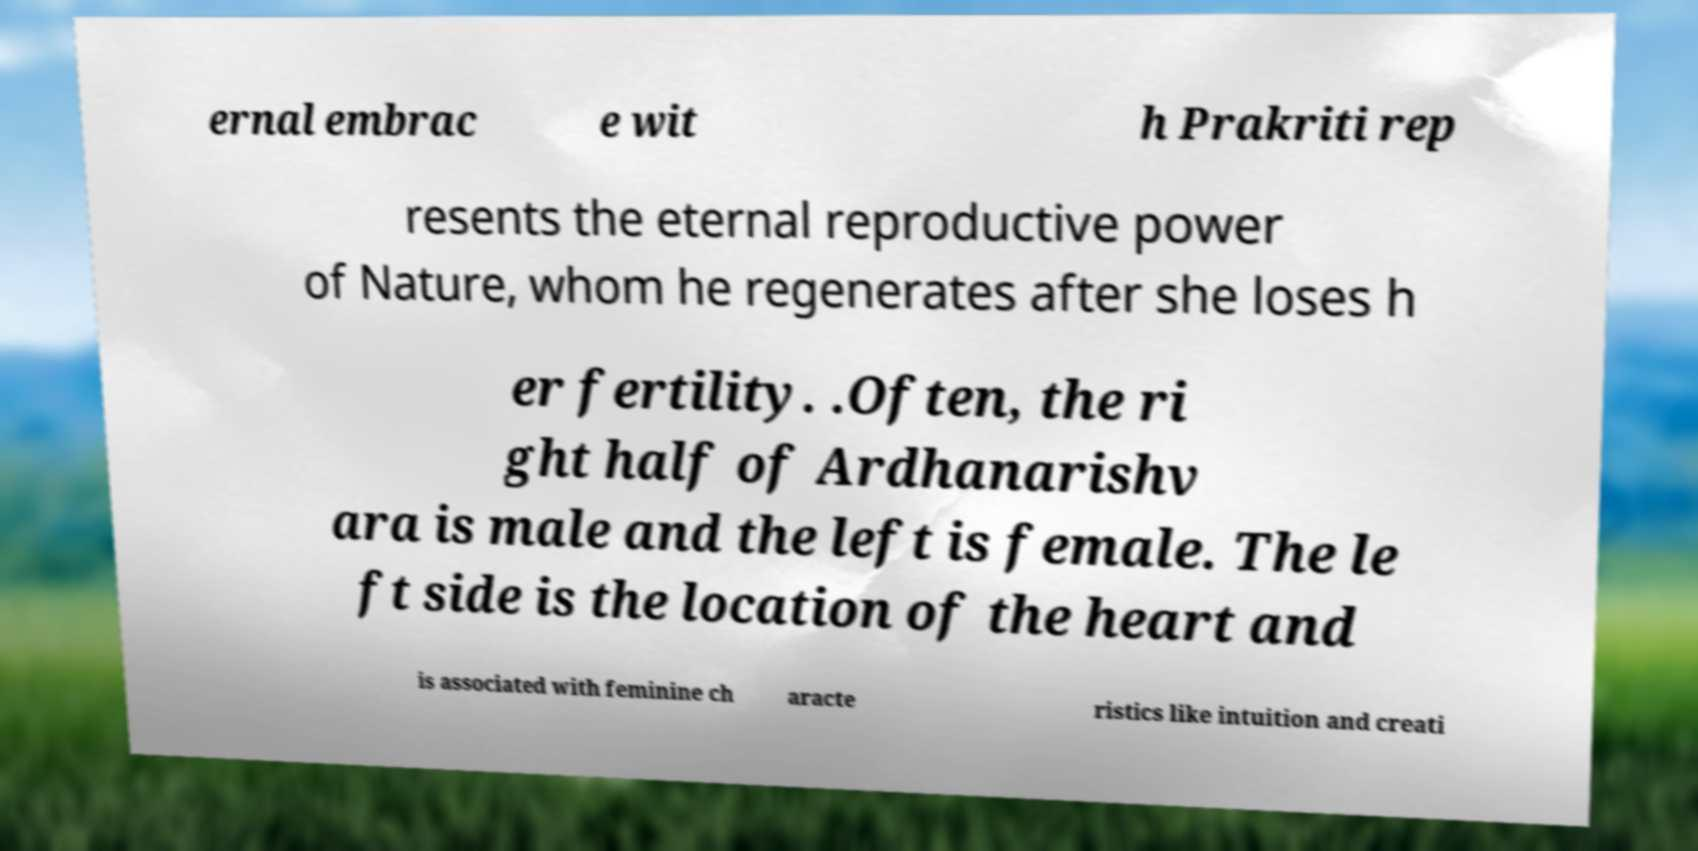Could you assist in decoding the text presented in this image and type it out clearly? ernal embrac e wit h Prakriti rep resents the eternal reproductive power of Nature, whom he regenerates after she loses h er fertility. .Often, the ri ght half of Ardhanarishv ara is male and the left is female. The le ft side is the location of the heart and is associated with feminine ch aracte ristics like intuition and creati 